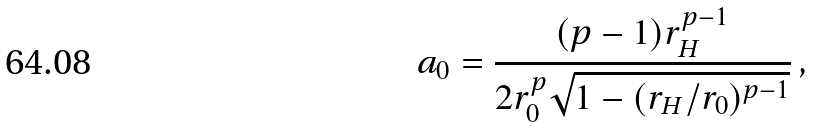Convert formula to latex. <formula><loc_0><loc_0><loc_500><loc_500>a _ { 0 } = \frac { ( p - 1 ) r _ { H } ^ { p - 1 } } { 2 r _ { 0 } ^ { p } \sqrt { 1 - ( r _ { H } / r _ { 0 } ) ^ { p - 1 } } } \, ,</formula> 